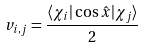<formula> <loc_0><loc_0><loc_500><loc_500>v _ { i , j } = \frac { \langle \chi _ { i } | \cos \hat { x } | \chi _ { j } \rangle } { 2 }</formula> 